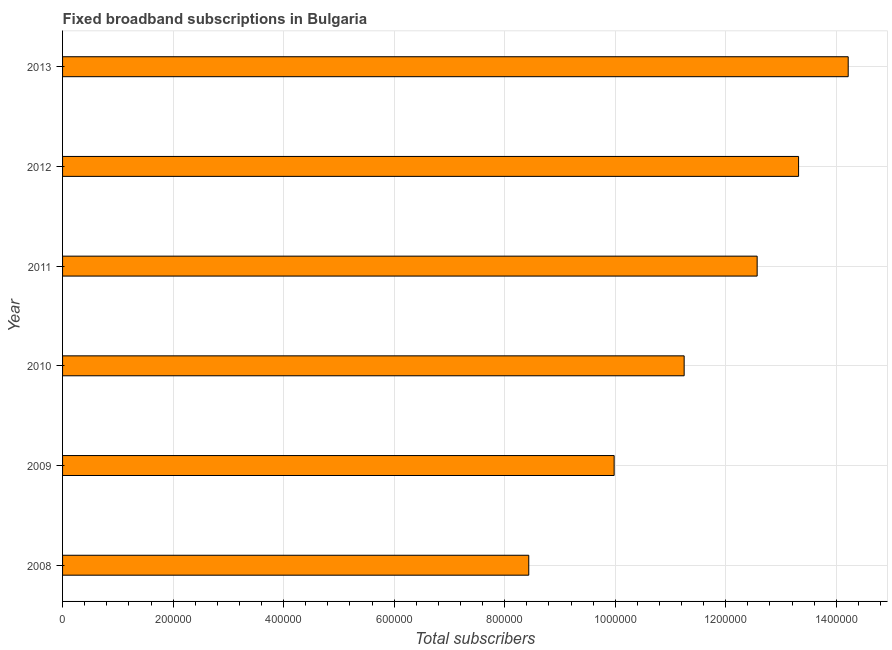Does the graph contain grids?
Keep it short and to the point. Yes. What is the title of the graph?
Keep it short and to the point. Fixed broadband subscriptions in Bulgaria. What is the label or title of the X-axis?
Offer a very short reply. Total subscribers. What is the total number of fixed broadband subscriptions in 2008?
Your answer should be compact. 8.44e+05. Across all years, what is the maximum total number of fixed broadband subscriptions?
Your answer should be compact. 1.42e+06. Across all years, what is the minimum total number of fixed broadband subscriptions?
Provide a succinct answer. 8.44e+05. What is the sum of the total number of fixed broadband subscriptions?
Provide a short and direct response. 6.98e+06. What is the difference between the total number of fixed broadband subscriptions in 2009 and 2012?
Your answer should be very brief. -3.34e+05. What is the average total number of fixed broadband subscriptions per year?
Provide a succinct answer. 1.16e+06. What is the median total number of fixed broadband subscriptions?
Keep it short and to the point. 1.19e+06. What is the ratio of the total number of fixed broadband subscriptions in 2010 to that in 2013?
Give a very brief answer. 0.79. Is the total number of fixed broadband subscriptions in 2009 less than that in 2013?
Offer a very short reply. Yes. Is the difference between the total number of fixed broadband subscriptions in 2009 and 2011 greater than the difference between any two years?
Your answer should be very brief. No. What is the difference between the highest and the second highest total number of fixed broadband subscriptions?
Provide a succinct answer. 8.98e+04. Is the sum of the total number of fixed broadband subscriptions in 2009 and 2013 greater than the maximum total number of fixed broadband subscriptions across all years?
Ensure brevity in your answer.  Yes. What is the difference between the highest and the lowest total number of fixed broadband subscriptions?
Provide a succinct answer. 5.78e+05. In how many years, is the total number of fixed broadband subscriptions greater than the average total number of fixed broadband subscriptions taken over all years?
Your response must be concise. 3. Are all the bars in the graph horizontal?
Ensure brevity in your answer.  Yes. How many years are there in the graph?
Your answer should be compact. 6. Are the values on the major ticks of X-axis written in scientific E-notation?
Offer a terse response. No. What is the Total subscribers of 2008?
Provide a short and direct response. 8.44e+05. What is the Total subscribers of 2009?
Your answer should be very brief. 9.98e+05. What is the Total subscribers of 2010?
Give a very brief answer. 1.12e+06. What is the Total subscribers of 2011?
Give a very brief answer. 1.26e+06. What is the Total subscribers of 2012?
Your response must be concise. 1.33e+06. What is the Total subscribers in 2013?
Give a very brief answer. 1.42e+06. What is the difference between the Total subscribers in 2008 and 2009?
Keep it short and to the point. -1.54e+05. What is the difference between the Total subscribers in 2008 and 2010?
Give a very brief answer. -2.81e+05. What is the difference between the Total subscribers in 2008 and 2011?
Make the answer very short. -4.13e+05. What is the difference between the Total subscribers in 2008 and 2012?
Make the answer very short. -4.88e+05. What is the difference between the Total subscribers in 2008 and 2013?
Make the answer very short. -5.78e+05. What is the difference between the Total subscribers in 2009 and 2010?
Offer a terse response. -1.27e+05. What is the difference between the Total subscribers in 2009 and 2011?
Your response must be concise. -2.59e+05. What is the difference between the Total subscribers in 2009 and 2012?
Provide a short and direct response. -3.34e+05. What is the difference between the Total subscribers in 2009 and 2013?
Keep it short and to the point. -4.24e+05. What is the difference between the Total subscribers in 2010 and 2011?
Your answer should be compact. -1.32e+05. What is the difference between the Total subscribers in 2010 and 2012?
Your response must be concise. -2.07e+05. What is the difference between the Total subscribers in 2010 and 2013?
Give a very brief answer. -2.97e+05. What is the difference between the Total subscribers in 2011 and 2012?
Give a very brief answer. -7.50e+04. What is the difference between the Total subscribers in 2011 and 2013?
Offer a very short reply. -1.65e+05. What is the difference between the Total subscribers in 2012 and 2013?
Ensure brevity in your answer.  -8.98e+04. What is the ratio of the Total subscribers in 2008 to that in 2009?
Make the answer very short. 0.84. What is the ratio of the Total subscribers in 2008 to that in 2011?
Make the answer very short. 0.67. What is the ratio of the Total subscribers in 2008 to that in 2012?
Keep it short and to the point. 0.63. What is the ratio of the Total subscribers in 2008 to that in 2013?
Offer a terse response. 0.59. What is the ratio of the Total subscribers in 2009 to that in 2010?
Keep it short and to the point. 0.89. What is the ratio of the Total subscribers in 2009 to that in 2011?
Keep it short and to the point. 0.79. What is the ratio of the Total subscribers in 2009 to that in 2012?
Provide a succinct answer. 0.75. What is the ratio of the Total subscribers in 2009 to that in 2013?
Offer a very short reply. 0.7. What is the ratio of the Total subscribers in 2010 to that in 2011?
Keep it short and to the point. 0.9. What is the ratio of the Total subscribers in 2010 to that in 2012?
Offer a very short reply. 0.84. What is the ratio of the Total subscribers in 2010 to that in 2013?
Your answer should be compact. 0.79. What is the ratio of the Total subscribers in 2011 to that in 2012?
Your answer should be compact. 0.94. What is the ratio of the Total subscribers in 2011 to that in 2013?
Offer a very short reply. 0.88. What is the ratio of the Total subscribers in 2012 to that in 2013?
Provide a succinct answer. 0.94. 